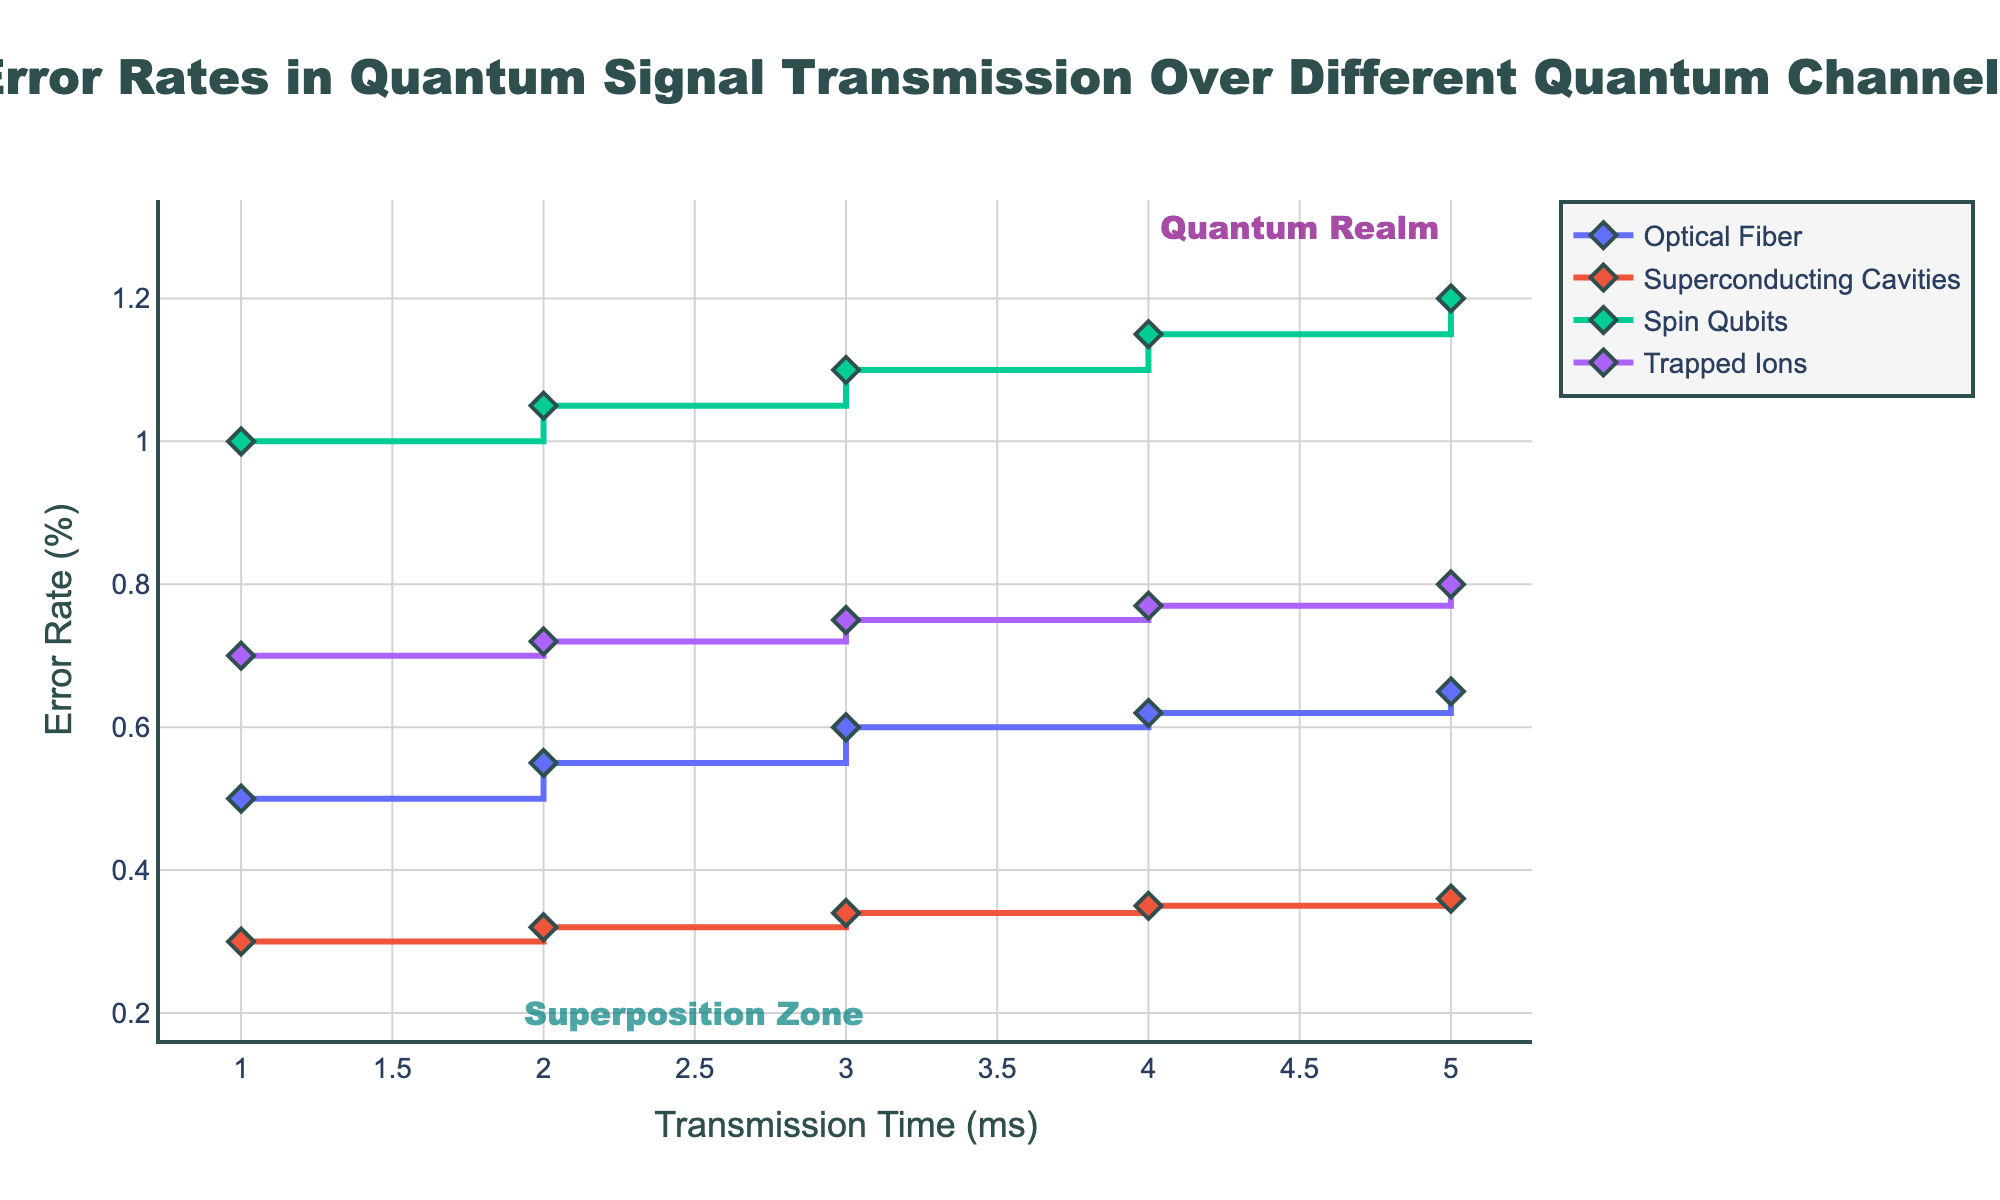What is the title of the figure? The title is written at the top center of the figure. It reads: "Error Rates in Quantum Signal Transmission Over Different Quantum Channels".
Answer: Error Rates in Quantum Signal Transmission Over Different Quantum Channels Which channel has the lowest error rate at 1 ms? Observing the y-values (Error Rate %) for all channels at the 1 ms x-value (Transmission Time), the lowest y-value corresponds to the "Superconducting Cavities" channel.
Answer: Superconducting Cavities How do the error rates of Optical Fiber and Spin Qubits compare at 2 ms? At 2 ms transmission time, we locate the error rates of both channels on the y-axis. Optical Fiber is at 0.55% and Spin Qubits are at 1.05%. Spin Qubits have higher error rates compared to Optical Fiber.
Answer: Spin Qubits have higher error rates What is the average error rate of Trapped Ions across all transmission times? We calculate the average by summing the error rates at each time point for Trapped Ions (0.7 + 0.72 + 0.75 + 0.77 + 0.8) and dividing by the number of time points, which is 5. The sum is 3.74, so the average is 3.74 / 5 = 0.748.
Answer: 0.748% Which channel shows the steepest increase in error rate over time? Steepness is indicated by the slope of the increase. Comparing the visual slopes of the line segments, the Spin Qubits channel shows the steepest rise in error rate over time.
Answer: Spin Qubits Explain the trend in error rates for the Superconducting Cavities channel. The Superconducting Cavities channel shows a gradual, almost linear increase in error rate. Starting from 0.3% at 1 ms to 0.36% at 5 ms, the error rate increases slightly with each increment in transmission time.
Answer: Gradual, almost linear increase Which quantum channel stays below a 1% error rate across all measured times? Each channel's error rate is plotted across multiple time intervals. Observing the graph, it's clear that Optical Fiber, Superconducting Cavities, and Trapped Ions remain below the 1% error threshold.
Answer: Optical Fiber, Superconducting Cavities, Trapped Ions Between which transmission times does Optical Fiber experience the largest error rate increase? We need to find the interval with the largest difference in error rates for Optical Fiber. The highest increase is from 1 ms to 2 ms, with a difference of 0.55% - 0.5% = 0.05%. Subsequent differences are smaller.
Answer: 1 ms to 2 ms What annotations are present in the figure and where are they located? The annotations "Quantum Realm" and "Superposition Zone" are present. "Quantum Realm" is near (4.5, 1.3) and "Superposition Zone" is near (2.5, 0.2).
Answer: Quantum Realm and Superposition Zone 